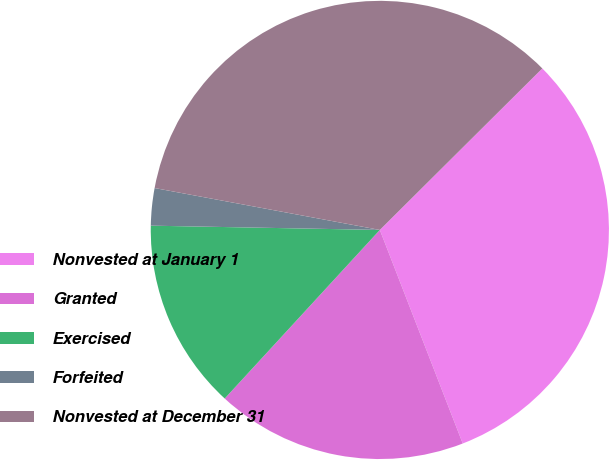<chart> <loc_0><loc_0><loc_500><loc_500><pie_chart><fcel>Nonvested at January 1<fcel>Granted<fcel>Exercised<fcel>Forfeited<fcel>Nonvested at December 31<nl><fcel>31.56%<fcel>17.73%<fcel>13.46%<fcel>2.63%<fcel>34.62%<nl></chart> 